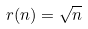Convert formula to latex. <formula><loc_0><loc_0><loc_500><loc_500>r ( n ) = \sqrt { n }</formula> 